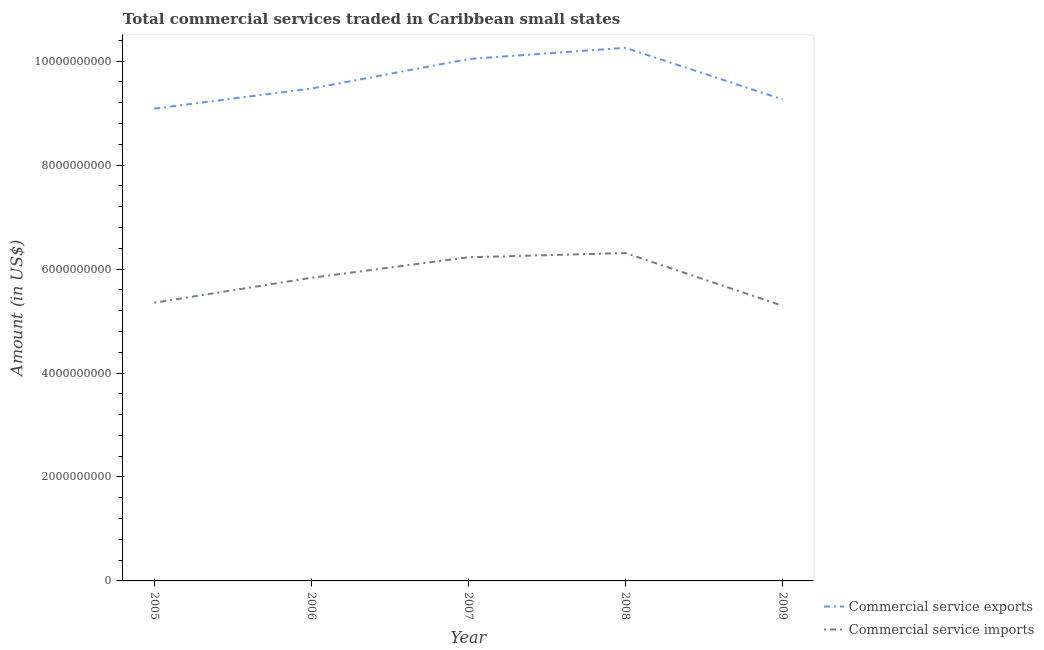How many different coloured lines are there?
Your answer should be compact. 2. Does the line corresponding to amount of commercial service exports intersect with the line corresponding to amount of commercial service imports?
Make the answer very short. No. What is the amount of commercial service exports in 2005?
Give a very brief answer. 9.09e+09. Across all years, what is the maximum amount of commercial service imports?
Offer a very short reply. 6.31e+09. Across all years, what is the minimum amount of commercial service exports?
Make the answer very short. 9.09e+09. In which year was the amount of commercial service exports minimum?
Provide a succinct answer. 2005. What is the total amount of commercial service exports in the graph?
Your response must be concise. 4.81e+1. What is the difference between the amount of commercial service imports in 2006 and that in 2008?
Provide a succinct answer. -4.76e+08. What is the difference between the amount of commercial service imports in 2007 and the amount of commercial service exports in 2008?
Your answer should be compact. -4.03e+09. What is the average amount of commercial service imports per year?
Provide a short and direct response. 5.80e+09. In the year 2007, what is the difference between the amount of commercial service exports and amount of commercial service imports?
Your answer should be compact. 3.81e+09. What is the ratio of the amount of commercial service exports in 2005 to that in 2007?
Provide a succinct answer. 0.9. What is the difference between the highest and the second highest amount of commercial service exports?
Your answer should be compact. 2.17e+08. What is the difference between the highest and the lowest amount of commercial service imports?
Your response must be concise. 1.01e+09. Does the amount of commercial service imports monotonically increase over the years?
Your response must be concise. No. Is the amount of commercial service exports strictly less than the amount of commercial service imports over the years?
Ensure brevity in your answer.  No. What is the difference between two consecutive major ticks on the Y-axis?
Offer a terse response. 2.00e+09. Does the graph contain any zero values?
Make the answer very short. No. Does the graph contain grids?
Offer a terse response. No. How many legend labels are there?
Offer a terse response. 2. How are the legend labels stacked?
Your answer should be compact. Vertical. What is the title of the graph?
Offer a very short reply. Total commercial services traded in Caribbean small states. Does "Depositors" appear as one of the legend labels in the graph?
Offer a terse response. No. What is the label or title of the X-axis?
Offer a terse response. Year. What is the Amount (in US$) in Commercial service exports in 2005?
Ensure brevity in your answer.  9.09e+09. What is the Amount (in US$) of Commercial service imports in 2005?
Your response must be concise. 5.35e+09. What is the Amount (in US$) in Commercial service exports in 2006?
Provide a succinct answer. 9.47e+09. What is the Amount (in US$) of Commercial service imports in 2006?
Your answer should be very brief. 5.83e+09. What is the Amount (in US$) in Commercial service exports in 2007?
Provide a succinct answer. 1.00e+1. What is the Amount (in US$) in Commercial service imports in 2007?
Provide a short and direct response. 6.23e+09. What is the Amount (in US$) of Commercial service exports in 2008?
Provide a short and direct response. 1.03e+1. What is the Amount (in US$) in Commercial service imports in 2008?
Your answer should be very brief. 6.31e+09. What is the Amount (in US$) of Commercial service exports in 2009?
Offer a very short reply. 9.26e+09. What is the Amount (in US$) of Commercial service imports in 2009?
Provide a short and direct response. 5.29e+09. Across all years, what is the maximum Amount (in US$) in Commercial service exports?
Provide a succinct answer. 1.03e+1. Across all years, what is the maximum Amount (in US$) of Commercial service imports?
Your answer should be compact. 6.31e+09. Across all years, what is the minimum Amount (in US$) of Commercial service exports?
Make the answer very short. 9.09e+09. Across all years, what is the minimum Amount (in US$) of Commercial service imports?
Provide a short and direct response. 5.29e+09. What is the total Amount (in US$) of Commercial service exports in the graph?
Offer a very short reply. 4.81e+1. What is the total Amount (in US$) of Commercial service imports in the graph?
Offer a very short reply. 2.90e+1. What is the difference between the Amount (in US$) of Commercial service exports in 2005 and that in 2006?
Your answer should be very brief. -3.86e+08. What is the difference between the Amount (in US$) of Commercial service imports in 2005 and that in 2006?
Offer a very short reply. -4.79e+08. What is the difference between the Amount (in US$) in Commercial service exports in 2005 and that in 2007?
Provide a short and direct response. -9.54e+08. What is the difference between the Amount (in US$) in Commercial service imports in 2005 and that in 2007?
Keep it short and to the point. -8.74e+08. What is the difference between the Amount (in US$) of Commercial service exports in 2005 and that in 2008?
Make the answer very short. -1.17e+09. What is the difference between the Amount (in US$) in Commercial service imports in 2005 and that in 2008?
Make the answer very short. -9.55e+08. What is the difference between the Amount (in US$) in Commercial service exports in 2005 and that in 2009?
Offer a very short reply. -1.77e+08. What is the difference between the Amount (in US$) of Commercial service imports in 2005 and that in 2009?
Make the answer very short. 5.87e+07. What is the difference between the Amount (in US$) of Commercial service exports in 2006 and that in 2007?
Make the answer very short. -5.68e+08. What is the difference between the Amount (in US$) of Commercial service imports in 2006 and that in 2007?
Give a very brief answer. -3.94e+08. What is the difference between the Amount (in US$) in Commercial service exports in 2006 and that in 2008?
Provide a succinct answer. -7.85e+08. What is the difference between the Amount (in US$) in Commercial service imports in 2006 and that in 2008?
Provide a short and direct response. -4.76e+08. What is the difference between the Amount (in US$) in Commercial service exports in 2006 and that in 2009?
Your answer should be compact. 2.09e+08. What is the difference between the Amount (in US$) of Commercial service imports in 2006 and that in 2009?
Provide a succinct answer. 5.38e+08. What is the difference between the Amount (in US$) in Commercial service exports in 2007 and that in 2008?
Provide a succinct answer. -2.17e+08. What is the difference between the Amount (in US$) in Commercial service imports in 2007 and that in 2008?
Offer a terse response. -8.18e+07. What is the difference between the Amount (in US$) of Commercial service exports in 2007 and that in 2009?
Offer a very short reply. 7.77e+08. What is the difference between the Amount (in US$) in Commercial service imports in 2007 and that in 2009?
Offer a terse response. 9.32e+08. What is the difference between the Amount (in US$) in Commercial service exports in 2008 and that in 2009?
Offer a terse response. 9.94e+08. What is the difference between the Amount (in US$) in Commercial service imports in 2008 and that in 2009?
Your answer should be very brief. 1.01e+09. What is the difference between the Amount (in US$) of Commercial service exports in 2005 and the Amount (in US$) of Commercial service imports in 2006?
Give a very brief answer. 3.25e+09. What is the difference between the Amount (in US$) in Commercial service exports in 2005 and the Amount (in US$) in Commercial service imports in 2007?
Offer a very short reply. 2.86e+09. What is the difference between the Amount (in US$) of Commercial service exports in 2005 and the Amount (in US$) of Commercial service imports in 2008?
Offer a terse response. 2.78e+09. What is the difference between the Amount (in US$) of Commercial service exports in 2005 and the Amount (in US$) of Commercial service imports in 2009?
Your answer should be compact. 3.79e+09. What is the difference between the Amount (in US$) of Commercial service exports in 2006 and the Amount (in US$) of Commercial service imports in 2007?
Offer a terse response. 3.25e+09. What is the difference between the Amount (in US$) in Commercial service exports in 2006 and the Amount (in US$) in Commercial service imports in 2008?
Offer a very short reply. 3.16e+09. What is the difference between the Amount (in US$) in Commercial service exports in 2006 and the Amount (in US$) in Commercial service imports in 2009?
Give a very brief answer. 4.18e+09. What is the difference between the Amount (in US$) in Commercial service exports in 2007 and the Amount (in US$) in Commercial service imports in 2008?
Your answer should be compact. 3.73e+09. What is the difference between the Amount (in US$) of Commercial service exports in 2007 and the Amount (in US$) of Commercial service imports in 2009?
Your response must be concise. 4.75e+09. What is the difference between the Amount (in US$) of Commercial service exports in 2008 and the Amount (in US$) of Commercial service imports in 2009?
Keep it short and to the point. 4.96e+09. What is the average Amount (in US$) of Commercial service exports per year?
Give a very brief answer. 9.62e+09. What is the average Amount (in US$) in Commercial service imports per year?
Make the answer very short. 5.80e+09. In the year 2005, what is the difference between the Amount (in US$) of Commercial service exports and Amount (in US$) of Commercial service imports?
Keep it short and to the point. 3.73e+09. In the year 2006, what is the difference between the Amount (in US$) of Commercial service exports and Amount (in US$) of Commercial service imports?
Give a very brief answer. 3.64e+09. In the year 2007, what is the difference between the Amount (in US$) of Commercial service exports and Amount (in US$) of Commercial service imports?
Ensure brevity in your answer.  3.81e+09. In the year 2008, what is the difference between the Amount (in US$) in Commercial service exports and Amount (in US$) in Commercial service imports?
Provide a short and direct response. 3.95e+09. In the year 2009, what is the difference between the Amount (in US$) in Commercial service exports and Amount (in US$) in Commercial service imports?
Ensure brevity in your answer.  3.97e+09. What is the ratio of the Amount (in US$) in Commercial service exports in 2005 to that in 2006?
Make the answer very short. 0.96. What is the ratio of the Amount (in US$) in Commercial service imports in 2005 to that in 2006?
Make the answer very short. 0.92. What is the ratio of the Amount (in US$) of Commercial service exports in 2005 to that in 2007?
Your answer should be very brief. 0.91. What is the ratio of the Amount (in US$) of Commercial service imports in 2005 to that in 2007?
Make the answer very short. 0.86. What is the ratio of the Amount (in US$) in Commercial service exports in 2005 to that in 2008?
Ensure brevity in your answer.  0.89. What is the ratio of the Amount (in US$) in Commercial service imports in 2005 to that in 2008?
Offer a terse response. 0.85. What is the ratio of the Amount (in US$) in Commercial service exports in 2005 to that in 2009?
Your answer should be compact. 0.98. What is the ratio of the Amount (in US$) in Commercial service imports in 2005 to that in 2009?
Provide a short and direct response. 1.01. What is the ratio of the Amount (in US$) in Commercial service exports in 2006 to that in 2007?
Provide a short and direct response. 0.94. What is the ratio of the Amount (in US$) of Commercial service imports in 2006 to that in 2007?
Provide a short and direct response. 0.94. What is the ratio of the Amount (in US$) in Commercial service exports in 2006 to that in 2008?
Give a very brief answer. 0.92. What is the ratio of the Amount (in US$) of Commercial service imports in 2006 to that in 2008?
Ensure brevity in your answer.  0.92. What is the ratio of the Amount (in US$) in Commercial service exports in 2006 to that in 2009?
Make the answer very short. 1.02. What is the ratio of the Amount (in US$) of Commercial service imports in 2006 to that in 2009?
Ensure brevity in your answer.  1.1. What is the ratio of the Amount (in US$) of Commercial service exports in 2007 to that in 2008?
Your answer should be very brief. 0.98. What is the ratio of the Amount (in US$) in Commercial service imports in 2007 to that in 2008?
Your response must be concise. 0.99. What is the ratio of the Amount (in US$) of Commercial service exports in 2007 to that in 2009?
Keep it short and to the point. 1.08. What is the ratio of the Amount (in US$) of Commercial service imports in 2007 to that in 2009?
Offer a very short reply. 1.18. What is the ratio of the Amount (in US$) of Commercial service exports in 2008 to that in 2009?
Offer a very short reply. 1.11. What is the ratio of the Amount (in US$) in Commercial service imports in 2008 to that in 2009?
Give a very brief answer. 1.19. What is the difference between the highest and the second highest Amount (in US$) of Commercial service exports?
Make the answer very short. 2.17e+08. What is the difference between the highest and the second highest Amount (in US$) of Commercial service imports?
Offer a terse response. 8.18e+07. What is the difference between the highest and the lowest Amount (in US$) in Commercial service exports?
Give a very brief answer. 1.17e+09. What is the difference between the highest and the lowest Amount (in US$) in Commercial service imports?
Your response must be concise. 1.01e+09. 